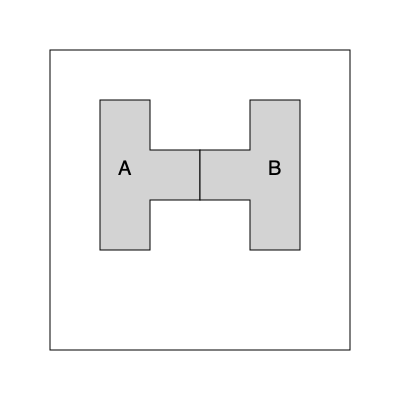In an abandoned mansion's locked safe, you find two oddly-shaped key items (A and B) that must be rotated and combined to fit perfectly into a square slot. How many 90-degree rotations are needed for both pieces combined to create a perfect square that fits the slot? To solve this spatial puzzle, let's approach it step-by-step:

1. Observe the shapes:
   - Shape A is an L-shaped piece
   - Shape B is a reversed L-shaped piece

2. Analyze the goal:
   - We need to form a perfect square using both pieces

3. Consider the current orientation:
   - In their current positions, the pieces don't form a square

4. Rotate Shape A:
   - Rotate A clockwise by 90 degrees (1 rotation)
   - It now fits the bottom-left corner of a potential square

5. Rotate Shape B:
   - Rotate B counterclockwise by 90 degrees (1 rotation)
   - It now fits the top-right corner, complementing Shape A

6. Check the result:
   - The two pieces now form a perfect square

7. Count total rotations:
   - Shape A: 1 rotation
   - Shape B: 1 rotation
   - Total: 1 + 1 = 2 rotations

Therefore, a total of 2 rotations (each 90 degrees) are needed to create a perfect square from the two key items.
Answer: 2 